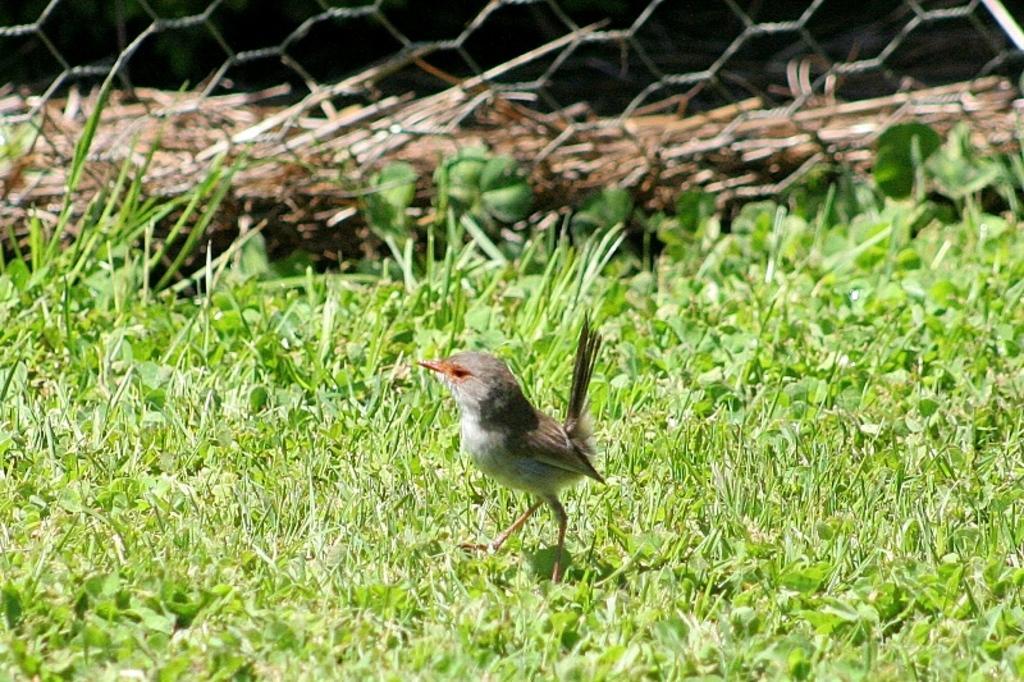In one or two sentences, can you explain what this image depicts? Here I can see a bird on the ground. On the ground I can see the green color grass. In the background there is a net and a trunk. 